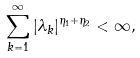<formula> <loc_0><loc_0><loc_500><loc_500>\sum _ { k = 1 } ^ { \infty } | \lambda _ { k } | ^ { \eta _ { 1 } + \eta _ { 2 } } < \infty ,</formula> 